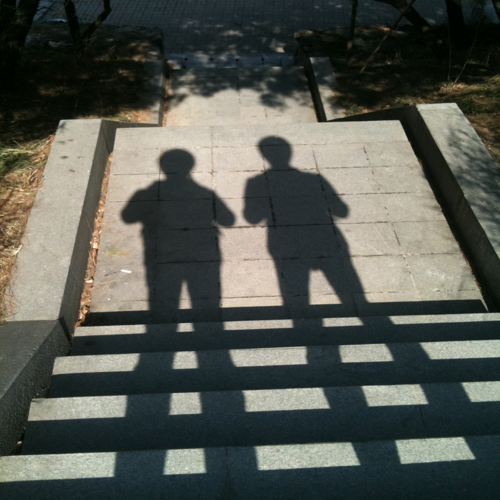How are the details of the background steps? The background steps exhibit a simple construction. They are made from concrete and have a regular, rectangular shape that contrasts with the shadows cast by a railing. The steps lead upwards in the image, inviting speculation about their destination. The sun casts distinct, parallel shadows from a handrail situated out of the immediate frame, creating a rhythmic pattern across the steps. 